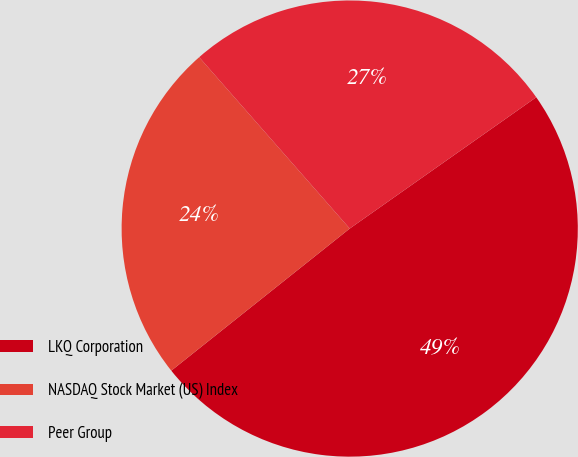<chart> <loc_0><loc_0><loc_500><loc_500><pie_chart><fcel>LKQ Corporation<fcel>NASDAQ Stock Market (US) Index<fcel>Peer Group<nl><fcel>49.06%<fcel>24.23%<fcel>26.71%<nl></chart> 